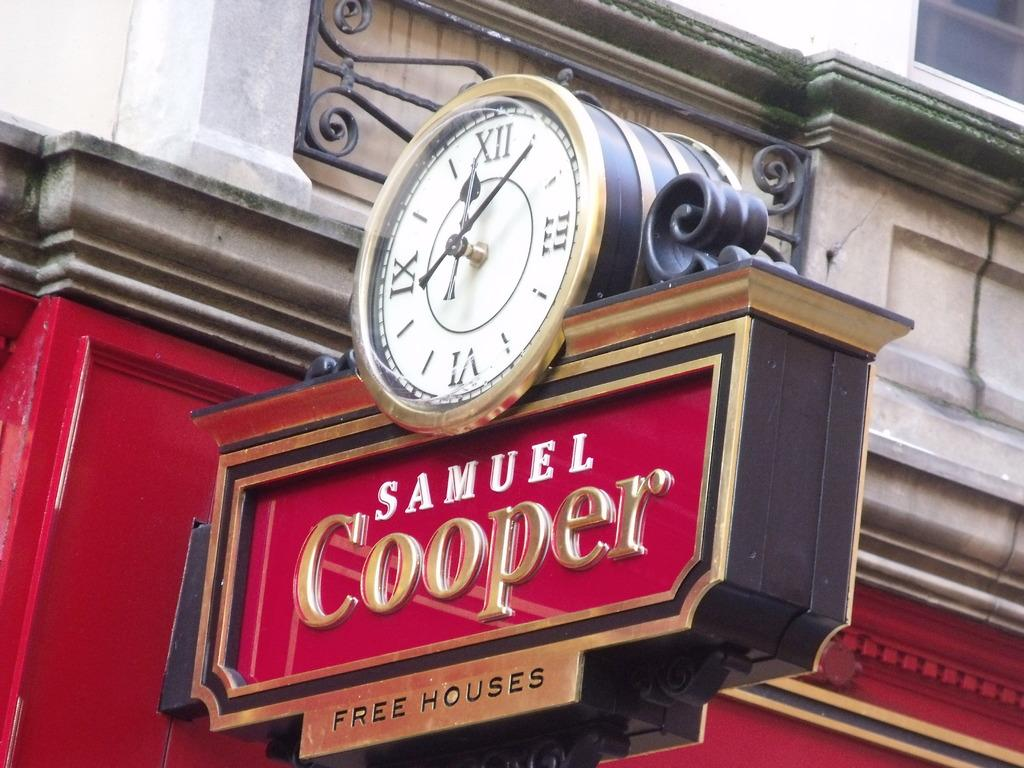<image>
Write a terse but informative summary of the picture. A sign that is red and a clock on top that says Samuel Cooper. 